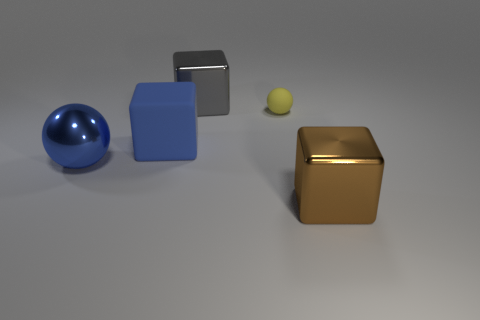Add 2 small purple metal cylinders. How many objects exist? 7 Subtract all yellow balls. How many balls are left? 1 Subtract all shiny cubes. How many cubes are left? 1 Subtract 0 green balls. How many objects are left? 5 Subtract all spheres. How many objects are left? 3 Subtract 1 balls. How many balls are left? 1 Subtract all blue cubes. Subtract all green cylinders. How many cubes are left? 2 Subtract all yellow cubes. How many blue spheres are left? 1 Subtract all small brown matte objects. Subtract all tiny yellow matte things. How many objects are left? 4 Add 5 brown metal cubes. How many brown metal cubes are left? 6 